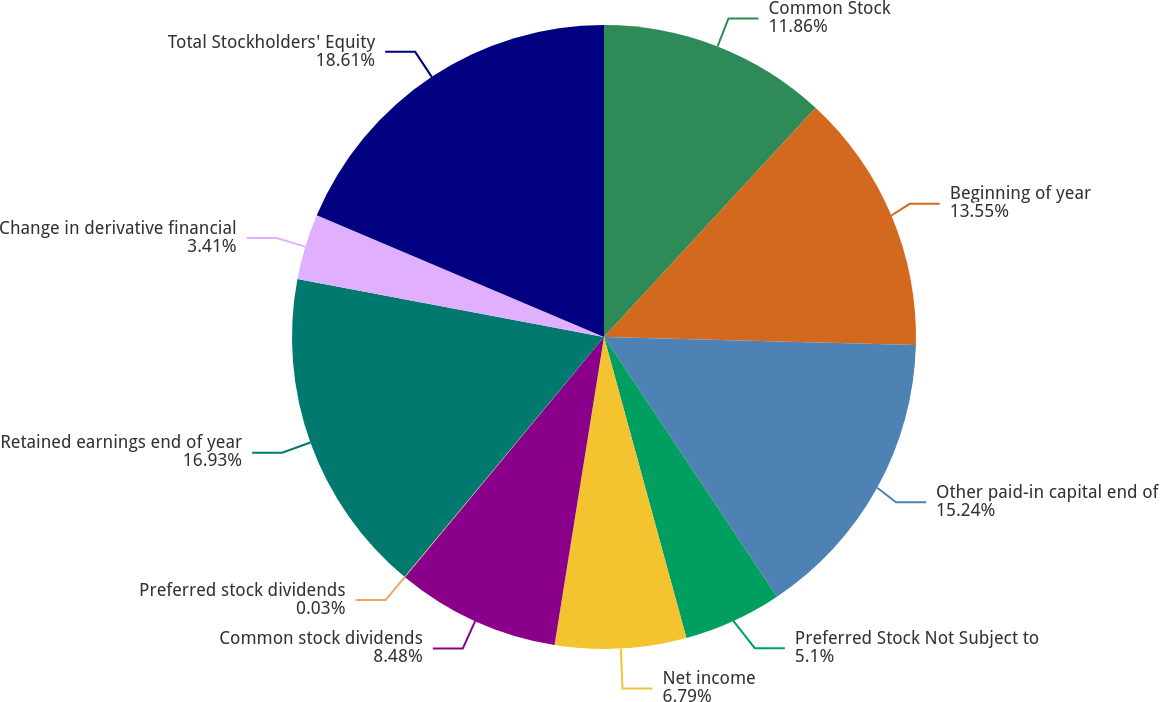Convert chart to OTSL. <chart><loc_0><loc_0><loc_500><loc_500><pie_chart><fcel>Common Stock<fcel>Beginning of year<fcel>Other paid-in capital end of<fcel>Preferred Stock Not Subject to<fcel>Net income<fcel>Common stock dividends<fcel>Preferred stock dividends<fcel>Retained earnings end of year<fcel>Change in derivative financial<fcel>Total Stockholders' Equity<nl><fcel>11.86%<fcel>13.55%<fcel>15.24%<fcel>5.1%<fcel>6.79%<fcel>8.48%<fcel>0.03%<fcel>16.93%<fcel>3.41%<fcel>18.62%<nl></chart> 